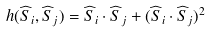Convert formula to latex. <formula><loc_0><loc_0><loc_500><loc_500>h ( \widehat { S } _ { i } , \widehat { S } _ { j } ) = \widehat { S } _ { i } \cdot \widehat { S } _ { j } + ( \widehat { S } _ { i } \cdot \widehat { S } _ { j } ) ^ { 2 }</formula> 